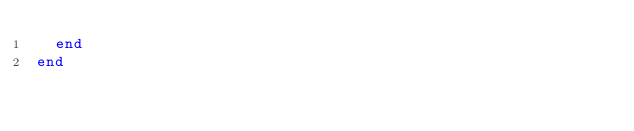Convert code to text. <code><loc_0><loc_0><loc_500><loc_500><_Ruby_>  end
end
</code> 